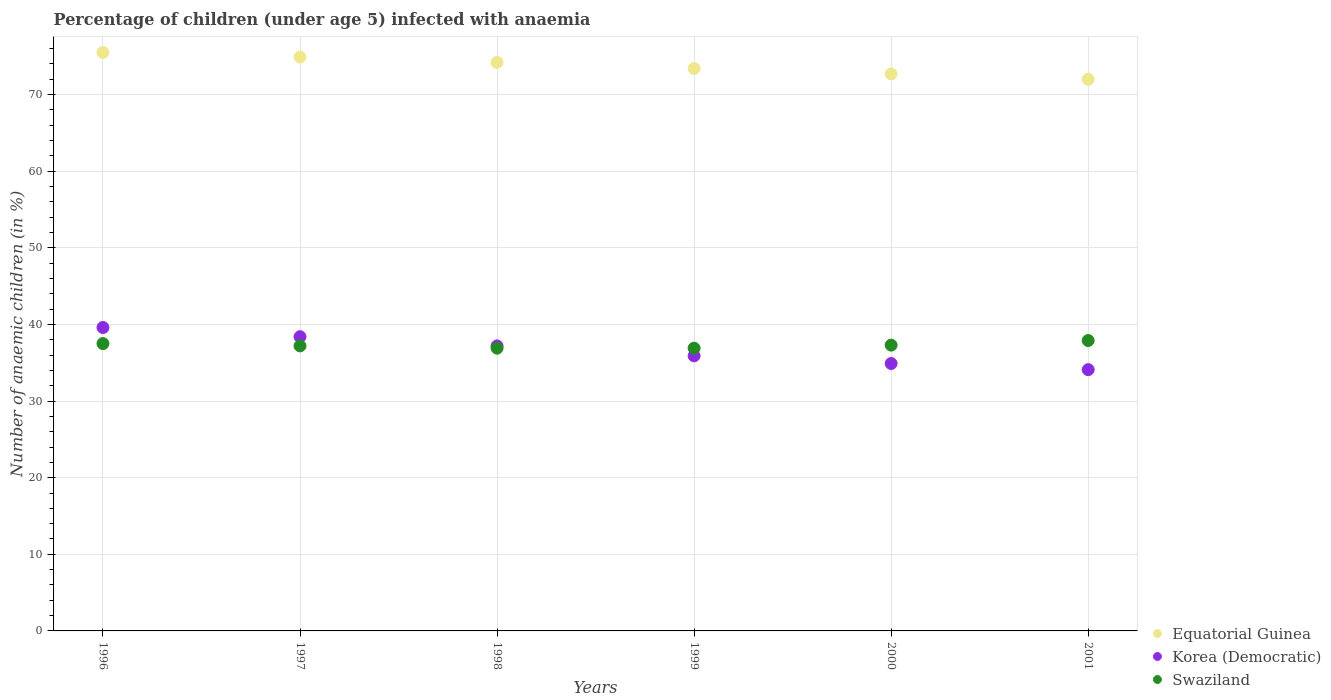What is the percentage of children infected with anaemia in in Swaziland in 1999?
Your answer should be compact. 36.9. Across all years, what is the maximum percentage of children infected with anaemia in in Korea (Democratic)?
Your response must be concise. 39.6. Across all years, what is the minimum percentage of children infected with anaemia in in Swaziland?
Your answer should be very brief. 36.9. In which year was the percentage of children infected with anaemia in in Equatorial Guinea maximum?
Offer a very short reply. 1996. In which year was the percentage of children infected with anaemia in in Equatorial Guinea minimum?
Ensure brevity in your answer.  2001. What is the total percentage of children infected with anaemia in in Korea (Democratic) in the graph?
Keep it short and to the point. 220.1. What is the difference between the percentage of children infected with anaemia in in Korea (Democratic) in 1996 and that in 2001?
Give a very brief answer. 5.5. What is the difference between the percentage of children infected with anaemia in in Equatorial Guinea in 2001 and the percentage of children infected with anaemia in in Swaziland in 1996?
Your answer should be very brief. 34.5. What is the average percentage of children infected with anaemia in in Korea (Democratic) per year?
Your response must be concise. 36.68. In the year 2000, what is the difference between the percentage of children infected with anaemia in in Equatorial Guinea and percentage of children infected with anaemia in in Korea (Democratic)?
Offer a very short reply. 37.8. What is the ratio of the percentage of children infected with anaemia in in Swaziland in 1999 to that in 2000?
Offer a very short reply. 0.99. Is the percentage of children infected with anaemia in in Korea (Democratic) in 1996 less than that in 1997?
Your answer should be very brief. No. Is the difference between the percentage of children infected with anaemia in in Equatorial Guinea in 2000 and 2001 greater than the difference between the percentage of children infected with anaemia in in Korea (Democratic) in 2000 and 2001?
Your answer should be compact. No. What is the difference between the highest and the second highest percentage of children infected with anaemia in in Swaziland?
Make the answer very short. 0.4. What is the difference between the highest and the lowest percentage of children infected with anaemia in in Swaziland?
Your answer should be very brief. 1. Is the percentage of children infected with anaemia in in Equatorial Guinea strictly greater than the percentage of children infected with anaemia in in Korea (Democratic) over the years?
Your answer should be compact. Yes. Is the percentage of children infected with anaemia in in Equatorial Guinea strictly less than the percentage of children infected with anaemia in in Korea (Democratic) over the years?
Ensure brevity in your answer.  No. How many years are there in the graph?
Ensure brevity in your answer.  6. What is the difference between two consecutive major ticks on the Y-axis?
Keep it short and to the point. 10. Does the graph contain any zero values?
Give a very brief answer. No. What is the title of the graph?
Your response must be concise. Percentage of children (under age 5) infected with anaemia. What is the label or title of the X-axis?
Your response must be concise. Years. What is the label or title of the Y-axis?
Ensure brevity in your answer.  Number of anaemic children (in %). What is the Number of anaemic children (in %) of Equatorial Guinea in 1996?
Your answer should be compact. 75.5. What is the Number of anaemic children (in %) of Korea (Democratic) in 1996?
Provide a short and direct response. 39.6. What is the Number of anaemic children (in %) of Swaziland in 1996?
Provide a short and direct response. 37.5. What is the Number of anaemic children (in %) in Equatorial Guinea in 1997?
Keep it short and to the point. 74.9. What is the Number of anaemic children (in %) in Korea (Democratic) in 1997?
Your answer should be very brief. 38.4. What is the Number of anaemic children (in %) in Swaziland in 1997?
Your response must be concise. 37.2. What is the Number of anaemic children (in %) of Equatorial Guinea in 1998?
Provide a short and direct response. 74.2. What is the Number of anaemic children (in %) of Korea (Democratic) in 1998?
Your answer should be very brief. 37.2. What is the Number of anaemic children (in %) of Swaziland in 1998?
Give a very brief answer. 36.9. What is the Number of anaemic children (in %) in Equatorial Guinea in 1999?
Ensure brevity in your answer.  73.4. What is the Number of anaemic children (in %) of Korea (Democratic) in 1999?
Your response must be concise. 35.9. What is the Number of anaemic children (in %) in Swaziland in 1999?
Offer a terse response. 36.9. What is the Number of anaemic children (in %) of Equatorial Guinea in 2000?
Provide a short and direct response. 72.7. What is the Number of anaemic children (in %) in Korea (Democratic) in 2000?
Your answer should be very brief. 34.9. What is the Number of anaemic children (in %) in Swaziland in 2000?
Keep it short and to the point. 37.3. What is the Number of anaemic children (in %) in Equatorial Guinea in 2001?
Offer a terse response. 72. What is the Number of anaemic children (in %) in Korea (Democratic) in 2001?
Make the answer very short. 34.1. What is the Number of anaemic children (in %) of Swaziland in 2001?
Your response must be concise. 37.9. Across all years, what is the maximum Number of anaemic children (in %) of Equatorial Guinea?
Keep it short and to the point. 75.5. Across all years, what is the maximum Number of anaemic children (in %) of Korea (Democratic)?
Offer a very short reply. 39.6. Across all years, what is the maximum Number of anaemic children (in %) of Swaziland?
Your answer should be very brief. 37.9. Across all years, what is the minimum Number of anaemic children (in %) in Korea (Democratic)?
Provide a succinct answer. 34.1. Across all years, what is the minimum Number of anaemic children (in %) of Swaziland?
Your answer should be very brief. 36.9. What is the total Number of anaemic children (in %) in Equatorial Guinea in the graph?
Your answer should be very brief. 442.7. What is the total Number of anaemic children (in %) of Korea (Democratic) in the graph?
Keep it short and to the point. 220.1. What is the total Number of anaemic children (in %) of Swaziland in the graph?
Your answer should be compact. 223.7. What is the difference between the Number of anaemic children (in %) in Korea (Democratic) in 1996 and that in 1997?
Your answer should be compact. 1.2. What is the difference between the Number of anaemic children (in %) in Equatorial Guinea in 1996 and that in 1998?
Provide a succinct answer. 1.3. What is the difference between the Number of anaemic children (in %) in Korea (Democratic) in 1996 and that in 1998?
Ensure brevity in your answer.  2.4. What is the difference between the Number of anaemic children (in %) of Equatorial Guinea in 1996 and that in 2000?
Offer a very short reply. 2.8. What is the difference between the Number of anaemic children (in %) in Equatorial Guinea in 1996 and that in 2001?
Your answer should be compact. 3.5. What is the difference between the Number of anaemic children (in %) in Swaziland in 1996 and that in 2001?
Ensure brevity in your answer.  -0.4. What is the difference between the Number of anaemic children (in %) of Equatorial Guinea in 1997 and that in 1998?
Your response must be concise. 0.7. What is the difference between the Number of anaemic children (in %) of Swaziland in 1997 and that in 1998?
Your answer should be compact. 0.3. What is the difference between the Number of anaemic children (in %) of Korea (Democratic) in 1997 and that in 2000?
Provide a succinct answer. 3.5. What is the difference between the Number of anaemic children (in %) in Korea (Democratic) in 1997 and that in 2001?
Ensure brevity in your answer.  4.3. What is the difference between the Number of anaemic children (in %) in Swaziland in 1997 and that in 2001?
Your answer should be compact. -0.7. What is the difference between the Number of anaemic children (in %) of Korea (Democratic) in 1998 and that in 1999?
Give a very brief answer. 1.3. What is the difference between the Number of anaemic children (in %) in Swaziland in 1998 and that in 1999?
Your response must be concise. 0. What is the difference between the Number of anaemic children (in %) of Equatorial Guinea in 1998 and that in 2001?
Your response must be concise. 2.2. What is the difference between the Number of anaemic children (in %) of Korea (Democratic) in 1998 and that in 2001?
Ensure brevity in your answer.  3.1. What is the difference between the Number of anaemic children (in %) in Swaziland in 1999 and that in 2000?
Offer a very short reply. -0.4. What is the difference between the Number of anaemic children (in %) in Equatorial Guinea in 1999 and that in 2001?
Provide a succinct answer. 1.4. What is the difference between the Number of anaemic children (in %) in Swaziland in 1999 and that in 2001?
Offer a terse response. -1. What is the difference between the Number of anaemic children (in %) in Equatorial Guinea in 2000 and that in 2001?
Your response must be concise. 0.7. What is the difference between the Number of anaemic children (in %) of Korea (Democratic) in 2000 and that in 2001?
Give a very brief answer. 0.8. What is the difference between the Number of anaemic children (in %) of Swaziland in 2000 and that in 2001?
Make the answer very short. -0.6. What is the difference between the Number of anaemic children (in %) in Equatorial Guinea in 1996 and the Number of anaemic children (in %) in Korea (Democratic) in 1997?
Your response must be concise. 37.1. What is the difference between the Number of anaemic children (in %) of Equatorial Guinea in 1996 and the Number of anaemic children (in %) of Swaziland in 1997?
Offer a terse response. 38.3. What is the difference between the Number of anaemic children (in %) of Equatorial Guinea in 1996 and the Number of anaemic children (in %) of Korea (Democratic) in 1998?
Make the answer very short. 38.3. What is the difference between the Number of anaemic children (in %) in Equatorial Guinea in 1996 and the Number of anaemic children (in %) in Swaziland in 1998?
Provide a succinct answer. 38.6. What is the difference between the Number of anaemic children (in %) in Korea (Democratic) in 1996 and the Number of anaemic children (in %) in Swaziland in 1998?
Ensure brevity in your answer.  2.7. What is the difference between the Number of anaemic children (in %) of Equatorial Guinea in 1996 and the Number of anaemic children (in %) of Korea (Democratic) in 1999?
Make the answer very short. 39.6. What is the difference between the Number of anaemic children (in %) in Equatorial Guinea in 1996 and the Number of anaemic children (in %) in Swaziland in 1999?
Your response must be concise. 38.6. What is the difference between the Number of anaemic children (in %) in Korea (Democratic) in 1996 and the Number of anaemic children (in %) in Swaziland in 1999?
Make the answer very short. 2.7. What is the difference between the Number of anaemic children (in %) of Equatorial Guinea in 1996 and the Number of anaemic children (in %) of Korea (Democratic) in 2000?
Your response must be concise. 40.6. What is the difference between the Number of anaemic children (in %) in Equatorial Guinea in 1996 and the Number of anaemic children (in %) in Swaziland in 2000?
Provide a short and direct response. 38.2. What is the difference between the Number of anaemic children (in %) in Equatorial Guinea in 1996 and the Number of anaemic children (in %) in Korea (Democratic) in 2001?
Give a very brief answer. 41.4. What is the difference between the Number of anaemic children (in %) of Equatorial Guinea in 1996 and the Number of anaemic children (in %) of Swaziland in 2001?
Provide a short and direct response. 37.6. What is the difference between the Number of anaemic children (in %) in Korea (Democratic) in 1996 and the Number of anaemic children (in %) in Swaziland in 2001?
Offer a very short reply. 1.7. What is the difference between the Number of anaemic children (in %) in Equatorial Guinea in 1997 and the Number of anaemic children (in %) in Korea (Democratic) in 1998?
Offer a terse response. 37.7. What is the difference between the Number of anaemic children (in %) of Equatorial Guinea in 1997 and the Number of anaemic children (in %) of Swaziland in 1998?
Make the answer very short. 38. What is the difference between the Number of anaemic children (in %) in Korea (Democratic) in 1997 and the Number of anaemic children (in %) in Swaziland in 1998?
Make the answer very short. 1.5. What is the difference between the Number of anaemic children (in %) in Equatorial Guinea in 1997 and the Number of anaemic children (in %) in Korea (Democratic) in 1999?
Ensure brevity in your answer.  39. What is the difference between the Number of anaemic children (in %) of Korea (Democratic) in 1997 and the Number of anaemic children (in %) of Swaziland in 1999?
Your answer should be very brief. 1.5. What is the difference between the Number of anaemic children (in %) of Equatorial Guinea in 1997 and the Number of anaemic children (in %) of Korea (Democratic) in 2000?
Make the answer very short. 40. What is the difference between the Number of anaemic children (in %) in Equatorial Guinea in 1997 and the Number of anaemic children (in %) in Swaziland in 2000?
Ensure brevity in your answer.  37.6. What is the difference between the Number of anaemic children (in %) of Equatorial Guinea in 1997 and the Number of anaemic children (in %) of Korea (Democratic) in 2001?
Offer a very short reply. 40.8. What is the difference between the Number of anaemic children (in %) in Equatorial Guinea in 1997 and the Number of anaemic children (in %) in Swaziland in 2001?
Offer a terse response. 37. What is the difference between the Number of anaemic children (in %) in Equatorial Guinea in 1998 and the Number of anaemic children (in %) in Korea (Democratic) in 1999?
Keep it short and to the point. 38.3. What is the difference between the Number of anaemic children (in %) in Equatorial Guinea in 1998 and the Number of anaemic children (in %) in Swaziland in 1999?
Provide a succinct answer. 37.3. What is the difference between the Number of anaemic children (in %) in Equatorial Guinea in 1998 and the Number of anaemic children (in %) in Korea (Democratic) in 2000?
Offer a terse response. 39.3. What is the difference between the Number of anaemic children (in %) in Equatorial Guinea in 1998 and the Number of anaemic children (in %) in Swaziland in 2000?
Your response must be concise. 36.9. What is the difference between the Number of anaemic children (in %) in Korea (Democratic) in 1998 and the Number of anaemic children (in %) in Swaziland in 2000?
Your response must be concise. -0.1. What is the difference between the Number of anaemic children (in %) of Equatorial Guinea in 1998 and the Number of anaemic children (in %) of Korea (Democratic) in 2001?
Offer a very short reply. 40.1. What is the difference between the Number of anaemic children (in %) in Equatorial Guinea in 1998 and the Number of anaemic children (in %) in Swaziland in 2001?
Offer a terse response. 36.3. What is the difference between the Number of anaemic children (in %) of Equatorial Guinea in 1999 and the Number of anaemic children (in %) of Korea (Democratic) in 2000?
Offer a very short reply. 38.5. What is the difference between the Number of anaemic children (in %) in Equatorial Guinea in 1999 and the Number of anaemic children (in %) in Swaziland in 2000?
Offer a terse response. 36.1. What is the difference between the Number of anaemic children (in %) in Equatorial Guinea in 1999 and the Number of anaemic children (in %) in Korea (Democratic) in 2001?
Your answer should be compact. 39.3. What is the difference between the Number of anaemic children (in %) of Equatorial Guinea in 1999 and the Number of anaemic children (in %) of Swaziland in 2001?
Ensure brevity in your answer.  35.5. What is the difference between the Number of anaemic children (in %) of Equatorial Guinea in 2000 and the Number of anaemic children (in %) of Korea (Democratic) in 2001?
Your answer should be compact. 38.6. What is the difference between the Number of anaemic children (in %) of Equatorial Guinea in 2000 and the Number of anaemic children (in %) of Swaziland in 2001?
Offer a very short reply. 34.8. What is the difference between the Number of anaemic children (in %) of Korea (Democratic) in 2000 and the Number of anaemic children (in %) of Swaziland in 2001?
Your response must be concise. -3. What is the average Number of anaemic children (in %) of Equatorial Guinea per year?
Provide a short and direct response. 73.78. What is the average Number of anaemic children (in %) of Korea (Democratic) per year?
Provide a succinct answer. 36.68. What is the average Number of anaemic children (in %) of Swaziland per year?
Ensure brevity in your answer.  37.28. In the year 1996, what is the difference between the Number of anaemic children (in %) of Equatorial Guinea and Number of anaemic children (in %) of Korea (Democratic)?
Your response must be concise. 35.9. In the year 1996, what is the difference between the Number of anaemic children (in %) of Equatorial Guinea and Number of anaemic children (in %) of Swaziland?
Ensure brevity in your answer.  38. In the year 1997, what is the difference between the Number of anaemic children (in %) of Equatorial Guinea and Number of anaemic children (in %) of Korea (Democratic)?
Your answer should be compact. 36.5. In the year 1997, what is the difference between the Number of anaemic children (in %) in Equatorial Guinea and Number of anaemic children (in %) in Swaziland?
Offer a very short reply. 37.7. In the year 1997, what is the difference between the Number of anaemic children (in %) of Korea (Democratic) and Number of anaemic children (in %) of Swaziland?
Your response must be concise. 1.2. In the year 1998, what is the difference between the Number of anaemic children (in %) of Equatorial Guinea and Number of anaemic children (in %) of Swaziland?
Give a very brief answer. 37.3. In the year 1999, what is the difference between the Number of anaemic children (in %) of Equatorial Guinea and Number of anaemic children (in %) of Korea (Democratic)?
Your answer should be compact. 37.5. In the year 1999, what is the difference between the Number of anaemic children (in %) in Equatorial Guinea and Number of anaemic children (in %) in Swaziland?
Your answer should be very brief. 36.5. In the year 2000, what is the difference between the Number of anaemic children (in %) of Equatorial Guinea and Number of anaemic children (in %) of Korea (Democratic)?
Keep it short and to the point. 37.8. In the year 2000, what is the difference between the Number of anaemic children (in %) in Equatorial Guinea and Number of anaemic children (in %) in Swaziland?
Keep it short and to the point. 35.4. In the year 2001, what is the difference between the Number of anaemic children (in %) of Equatorial Guinea and Number of anaemic children (in %) of Korea (Democratic)?
Make the answer very short. 37.9. In the year 2001, what is the difference between the Number of anaemic children (in %) of Equatorial Guinea and Number of anaemic children (in %) of Swaziland?
Provide a short and direct response. 34.1. In the year 2001, what is the difference between the Number of anaemic children (in %) in Korea (Democratic) and Number of anaemic children (in %) in Swaziland?
Give a very brief answer. -3.8. What is the ratio of the Number of anaemic children (in %) in Korea (Democratic) in 1996 to that in 1997?
Your answer should be compact. 1.03. What is the ratio of the Number of anaemic children (in %) of Swaziland in 1996 to that in 1997?
Your answer should be very brief. 1.01. What is the ratio of the Number of anaemic children (in %) in Equatorial Guinea in 1996 to that in 1998?
Make the answer very short. 1.02. What is the ratio of the Number of anaemic children (in %) of Korea (Democratic) in 1996 to that in 1998?
Provide a short and direct response. 1.06. What is the ratio of the Number of anaemic children (in %) of Swaziland in 1996 to that in 1998?
Ensure brevity in your answer.  1.02. What is the ratio of the Number of anaemic children (in %) in Equatorial Guinea in 1996 to that in 1999?
Give a very brief answer. 1.03. What is the ratio of the Number of anaemic children (in %) in Korea (Democratic) in 1996 to that in 1999?
Offer a very short reply. 1.1. What is the ratio of the Number of anaemic children (in %) in Swaziland in 1996 to that in 1999?
Ensure brevity in your answer.  1.02. What is the ratio of the Number of anaemic children (in %) in Korea (Democratic) in 1996 to that in 2000?
Provide a short and direct response. 1.13. What is the ratio of the Number of anaemic children (in %) of Swaziland in 1996 to that in 2000?
Your answer should be compact. 1.01. What is the ratio of the Number of anaemic children (in %) in Equatorial Guinea in 1996 to that in 2001?
Keep it short and to the point. 1.05. What is the ratio of the Number of anaemic children (in %) of Korea (Democratic) in 1996 to that in 2001?
Offer a very short reply. 1.16. What is the ratio of the Number of anaemic children (in %) of Equatorial Guinea in 1997 to that in 1998?
Ensure brevity in your answer.  1.01. What is the ratio of the Number of anaemic children (in %) of Korea (Democratic) in 1997 to that in 1998?
Give a very brief answer. 1.03. What is the ratio of the Number of anaemic children (in %) in Swaziland in 1997 to that in 1998?
Give a very brief answer. 1.01. What is the ratio of the Number of anaemic children (in %) in Equatorial Guinea in 1997 to that in 1999?
Give a very brief answer. 1.02. What is the ratio of the Number of anaemic children (in %) in Korea (Democratic) in 1997 to that in 1999?
Offer a terse response. 1.07. What is the ratio of the Number of anaemic children (in %) of Equatorial Guinea in 1997 to that in 2000?
Provide a succinct answer. 1.03. What is the ratio of the Number of anaemic children (in %) in Korea (Democratic) in 1997 to that in 2000?
Provide a succinct answer. 1.1. What is the ratio of the Number of anaemic children (in %) of Swaziland in 1997 to that in 2000?
Provide a succinct answer. 1. What is the ratio of the Number of anaemic children (in %) in Equatorial Guinea in 1997 to that in 2001?
Your answer should be compact. 1.04. What is the ratio of the Number of anaemic children (in %) of Korea (Democratic) in 1997 to that in 2001?
Keep it short and to the point. 1.13. What is the ratio of the Number of anaemic children (in %) of Swaziland in 1997 to that in 2001?
Give a very brief answer. 0.98. What is the ratio of the Number of anaemic children (in %) in Equatorial Guinea in 1998 to that in 1999?
Offer a terse response. 1.01. What is the ratio of the Number of anaemic children (in %) in Korea (Democratic) in 1998 to that in 1999?
Your response must be concise. 1.04. What is the ratio of the Number of anaemic children (in %) in Swaziland in 1998 to that in 1999?
Offer a very short reply. 1. What is the ratio of the Number of anaemic children (in %) of Equatorial Guinea in 1998 to that in 2000?
Your answer should be compact. 1.02. What is the ratio of the Number of anaemic children (in %) of Korea (Democratic) in 1998 to that in 2000?
Your response must be concise. 1.07. What is the ratio of the Number of anaemic children (in %) of Swaziland in 1998 to that in 2000?
Make the answer very short. 0.99. What is the ratio of the Number of anaemic children (in %) of Equatorial Guinea in 1998 to that in 2001?
Your answer should be very brief. 1.03. What is the ratio of the Number of anaemic children (in %) in Swaziland in 1998 to that in 2001?
Provide a succinct answer. 0.97. What is the ratio of the Number of anaemic children (in %) in Equatorial Guinea in 1999 to that in 2000?
Keep it short and to the point. 1.01. What is the ratio of the Number of anaemic children (in %) of Korea (Democratic) in 1999 to that in 2000?
Give a very brief answer. 1.03. What is the ratio of the Number of anaemic children (in %) in Swaziland in 1999 to that in 2000?
Keep it short and to the point. 0.99. What is the ratio of the Number of anaemic children (in %) of Equatorial Guinea in 1999 to that in 2001?
Keep it short and to the point. 1.02. What is the ratio of the Number of anaemic children (in %) in Korea (Democratic) in 1999 to that in 2001?
Provide a short and direct response. 1.05. What is the ratio of the Number of anaemic children (in %) of Swaziland in 1999 to that in 2001?
Your response must be concise. 0.97. What is the ratio of the Number of anaemic children (in %) in Equatorial Guinea in 2000 to that in 2001?
Offer a terse response. 1.01. What is the ratio of the Number of anaemic children (in %) of Korea (Democratic) in 2000 to that in 2001?
Keep it short and to the point. 1.02. What is the ratio of the Number of anaemic children (in %) of Swaziland in 2000 to that in 2001?
Your answer should be compact. 0.98. What is the difference between the highest and the lowest Number of anaemic children (in %) of Korea (Democratic)?
Your answer should be very brief. 5.5. 